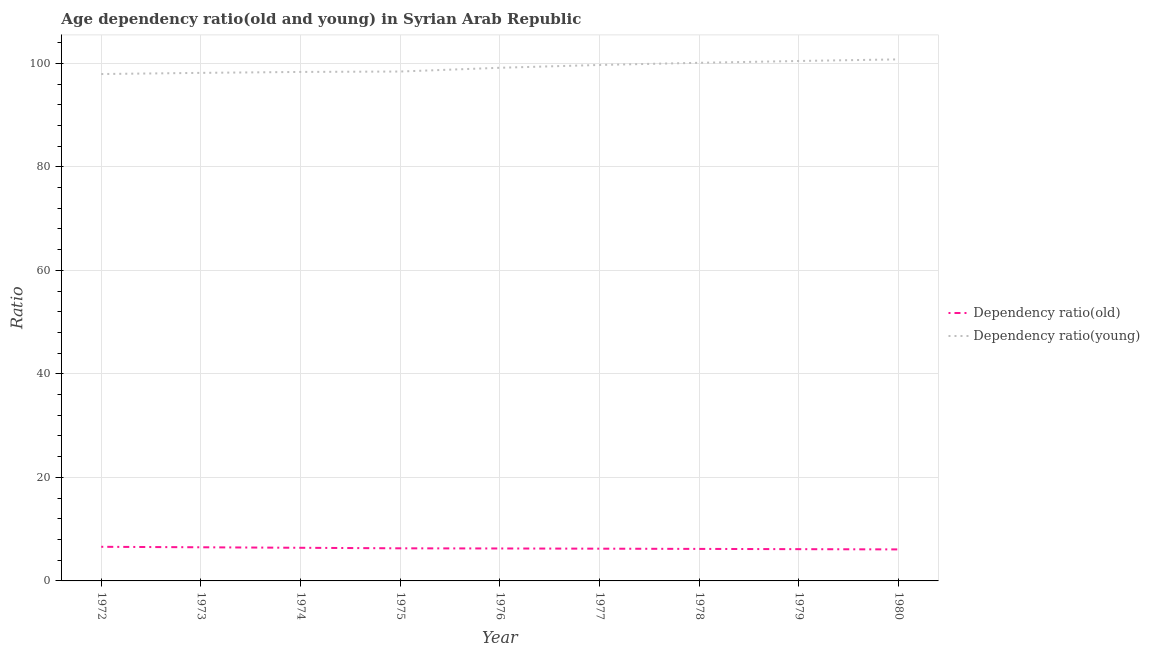Does the line corresponding to age dependency ratio(young) intersect with the line corresponding to age dependency ratio(old)?
Your answer should be very brief. No. Is the number of lines equal to the number of legend labels?
Provide a short and direct response. Yes. What is the age dependency ratio(young) in 1976?
Make the answer very short. 99.14. Across all years, what is the maximum age dependency ratio(old)?
Give a very brief answer. 6.59. Across all years, what is the minimum age dependency ratio(young)?
Offer a very short reply. 97.93. In which year was the age dependency ratio(old) maximum?
Your response must be concise. 1972. What is the total age dependency ratio(young) in the graph?
Keep it short and to the point. 893.01. What is the difference between the age dependency ratio(young) in 1977 and that in 1980?
Offer a very short reply. -1.08. What is the difference between the age dependency ratio(old) in 1979 and the age dependency ratio(young) in 1976?
Offer a terse response. -93.01. What is the average age dependency ratio(young) per year?
Your answer should be very brief. 99.22. In the year 1973, what is the difference between the age dependency ratio(young) and age dependency ratio(old)?
Make the answer very short. 91.66. In how many years, is the age dependency ratio(young) greater than 84?
Give a very brief answer. 9. What is the ratio of the age dependency ratio(young) in 1974 to that in 1978?
Give a very brief answer. 0.98. Is the age dependency ratio(young) in 1973 less than that in 1978?
Provide a succinct answer. Yes. What is the difference between the highest and the second highest age dependency ratio(young)?
Offer a terse response. 0.31. What is the difference between the highest and the lowest age dependency ratio(old)?
Make the answer very short. 0.5. Does the age dependency ratio(old) monotonically increase over the years?
Give a very brief answer. No. Is the age dependency ratio(young) strictly greater than the age dependency ratio(old) over the years?
Provide a succinct answer. Yes. Is the age dependency ratio(old) strictly less than the age dependency ratio(young) over the years?
Offer a very short reply. Yes. How many lines are there?
Offer a terse response. 2. Are the values on the major ticks of Y-axis written in scientific E-notation?
Keep it short and to the point. No. How many legend labels are there?
Offer a very short reply. 2. How are the legend labels stacked?
Your answer should be compact. Vertical. What is the title of the graph?
Provide a short and direct response. Age dependency ratio(old and young) in Syrian Arab Republic. Does "Nonresident" appear as one of the legend labels in the graph?
Ensure brevity in your answer.  No. What is the label or title of the Y-axis?
Ensure brevity in your answer.  Ratio. What is the Ratio in Dependency ratio(old) in 1972?
Offer a very short reply. 6.59. What is the Ratio in Dependency ratio(young) in 1972?
Give a very brief answer. 97.93. What is the Ratio of Dependency ratio(old) in 1973?
Offer a very short reply. 6.5. What is the Ratio of Dependency ratio(young) in 1973?
Provide a short and direct response. 98.16. What is the Ratio in Dependency ratio(old) in 1974?
Provide a short and direct response. 6.4. What is the Ratio in Dependency ratio(young) in 1974?
Your response must be concise. 98.34. What is the Ratio of Dependency ratio(old) in 1975?
Keep it short and to the point. 6.3. What is the Ratio in Dependency ratio(young) in 1975?
Ensure brevity in your answer.  98.42. What is the Ratio of Dependency ratio(old) in 1976?
Your answer should be compact. 6.27. What is the Ratio of Dependency ratio(young) in 1976?
Provide a short and direct response. 99.14. What is the Ratio of Dependency ratio(old) in 1977?
Your response must be concise. 6.23. What is the Ratio of Dependency ratio(young) in 1977?
Offer a very short reply. 99.69. What is the Ratio in Dependency ratio(old) in 1978?
Give a very brief answer. 6.19. What is the Ratio of Dependency ratio(young) in 1978?
Keep it short and to the point. 100.1. What is the Ratio in Dependency ratio(old) in 1979?
Your answer should be very brief. 6.14. What is the Ratio in Dependency ratio(young) in 1979?
Provide a succinct answer. 100.46. What is the Ratio in Dependency ratio(old) in 1980?
Offer a terse response. 6.09. What is the Ratio of Dependency ratio(young) in 1980?
Ensure brevity in your answer.  100.77. Across all years, what is the maximum Ratio in Dependency ratio(old)?
Give a very brief answer. 6.59. Across all years, what is the maximum Ratio of Dependency ratio(young)?
Your response must be concise. 100.77. Across all years, what is the minimum Ratio of Dependency ratio(old)?
Provide a short and direct response. 6.09. Across all years, what is the minimum Ratio in Dependency ratio(young)?
Offer a terse response. 97.93. What is the total Ratio in Dependency ratio(old) in the graph?
Your answer should be compact. 56.71. What is the total Ratio in Dependency ratio(young) in the graph?
Make the answer very short. 893.01. What is the difference between the Ratio in Dependency ratio(old) in 1972 and that in 1973?
Offer a very short reply. 0.09. What is the difference between the Ratio of Dependency ratio(young) in 1972 and that in 1973?
Your response must be concise. -0.22. What is the difference between the Ratio in Dependency ratio(old) in 1972 and that in 1974?
Your answer should be very brief. 0.19. What is the difference between the Ratio in Dependency ratio(young) in 1972 and that in 1974?
Make the answer very short. -0.41. What is the difference between the Ratio in Dependency ratio(old) in 1972 and that in 1975?
Keep it short and to the point. 0.29. What is the difference between the Ratio in Dependency ratio(young) in 1972 and that in 1975?
Ensure brevity in your answer.  -0.49. What is the difference between the Ratio in Dependency ratio(old) in 1972 and that in 1976?
Offer a terse response. 0.32. What is the difference between the Ratio of Dependency ratio(young) in 1972 and that in 1976?
Keep it short and to the point. -1.21. What is the difference between the Ratio in Dependency ratio(old) in 1972 and that in 1977?
Your answer should be compact. 0.36. What is the difference between the Ratio in Dependency ratio(young) in 1972 and that in 1977?
Ensure brevity in your answer.  -1.75. What is the difference between the Ratio in Dependency ratio(old) in 1972 and that in 1978?
Your answer should be very brief. 0.41. What is the difference between the Ratio of Dependency ratio(young) in 1972 and that in 1978?
Your response must be concise. -2.17. What is the difference between the Ratio of Dependency ratio(old) in 1972 and that in 1979?
Your answer should be compact. 0.45. What is the difference between the Ratio in Dependency ratio(young) in 1972 and that in 1979?
Keep it short and to the point. -2.52. What is the difference between the Ratio in Dependency ratio(old) in 1972 and that in 1980?
Your answer should be very brief. 0.5. What is the difference between the Ratio in Dependency ratio(young) in 1972 and that in 1980?
Offer a very short reply. -2.83. What is the difference between the Ratio in Dependency ratio(old) in 1973 and that in 1974?
Your answer should be very brief. 0.1. What is the difference between the Ratio in Dependency ratio(young) in 1973 and that in 1974?
Your answer should be compact. -0.18. What is the difference between the Ratio of Dependency ratio(old) in 1973 and that in 1975?
Offer a terse response. 0.2. What is the difference between the Ratio of Dependency ratio(young) in 1973 and that in 1975?
Offer a very short reply. -0.26. What is the difference between the Ratio in Dependency ratio(old) in 1973 and that in 1976?
Offer a terse response. 0.23. What is the difference between the Ratio of Dependency ratio(young) in 1973 and that in 1976?
Your response must be concise. -0.99. What is the difference between the Ratio in Dependency ratio(old) in 1973 and that in 1977?
Ensure brevity in your answer.  0.27. What is the difference between the Ratio of Dependency ratio(young) in 1973 and that in 1977?
Make the answer very short. -1.53. What is the difference between the Ratio of Dependency ratio(old) in 1973 and that in 1978?
Provide a short and direct response. 0.31. What is the difference between the Ratio in Dependency ratio(young) in 1973 and that in 1978?
Provide a succinct answer. -1.95. What is the difference between the Ratio in Dependency ratio(old) in 1973 and that in 1979?
Give a very brief answer. 0.36. What is the difference between the Ratio in Dependency ratio(young) in 1973 and that in 1979?
Give a very brief answer. -2.3. What is the difference between the Ratio in Dependency ratio(old) in 1973 and that in 1980?
Your answer should be compact. 0.41. What is the difference between the Ratio of Dependency ratio(young) in 1973 and that in 1980?
Your response must be concise. -2.61. What is the difference between the Ratio of Dependency ratio(old) in 1974 and that in 1975?
Keep it short and to the point. 0.1. What is the difference between the Ratio in Dependency ratio(young) in 1974 and that in 1975?
Your answer should be compact. -0.08. What is the difference between the Ratio in Dependency ratio(old) in 1974 and that in 1976?
Give a very brief answer. 0.13. What is the difference between the Ratio in Dependency ratio(young) in 1974 and that in 1976?
Give a very brief answer. -0.8. What is the difference between the Ratio in Dependency ratio(old) in 1974 and that in 1977?
Offer a very short reply. 0.17. What is the difference between the Ratio of Dependency ratio(young) in 1974 and that in 1977?
Make the answer very short. -1.35. What is the difference between the Ratio in Dependency ratio(old) in 1974 and that in 1978?
Give a very brief answer. 0.22. What is the difference between the Ratio of Dependency ratio(young) in 1974 and that in 1978?
Offer a very short reply. -1.76. What is the difference between the Ratio in Dependency ratio(old) in 1974 and that in 1979?
Your response must be concise. 0.26. What is the difference between the Ratio in Dependency ratio(young) in 1974 and that in 1979?
Keep it short and to the point. -2.12. What is the difference between the Ratio in Dependency ratio(old) in 1974 and that in 1980?
Provide a succinct answer. 0.31. What is the difference between the Ratio in Dependency ratio(young) in 1974 and that in 1980?
Your response must be concise. -2.43. What is the difference between the Ratio in Dependency ratio(old) in 1975 and that in 1976?
Make the answer very short. 0.03. What is the difference between the Ratio of Dependency ratio(young) in 1975 and that in 1976?
Provide a short and direct response. -0.72. What is the difference between the Ratio in Dependency ratio(old) in 1975 and that in 1977?
Offer a very short reply. 0.07. What is the difference between the Ratio in Dependency ratio(young) in 1975 and that in 1977?
Keep it short and to the point. -1.27. What is the difference between the Ratio in Dependency ratio(old) in 1975 and that in 1978?
Offer a terse response. 0.11. What is the difference between the Ratio of Dependency ratio(young) in 1975 and that in 1978?
Make the answer very short. -1.68. What is the difference between the Ratio in Dependency ratio(old) in 1975 and that in 1979?
Give a very brief answer. 0.16. What is the difference between the Ratio in Dependency ratio(young) in 1975 and that in 1979?
Offer a terse response. -2.04. What is the difference between the Ratio of Dependency ratio(old) in 1975 and that in 1980?
Your response must be concise. 0.21. What is the difference between the Ratio in Dependency ratio(young) in 1975 and that in 1980?
Provide a short and direct response. -2.35. What is the difference between the Ratio in Dependency ratio(old) in 1976 and that in 1977?
Offer a terse response. 0.04. What is the difference between the Ratio in Dependency ratio(young) in 1976 and that in 1977?
Your answer should be compact. -0.55. What is the difference between the Ratio of Dependency ratio(old) in 1976 and that in 1978?
Your answer should be compact. 0.08. What is the difference between the Ratio in Dependency ratio(young) in 1976 and that in 1978?
Provide a succinct answer. -0.96. What is the difference between the Ratio of Dependency ratio(old) in 1976 and that in 1979?
Offer a terse response. 0.13. What is the difference between the Ratio in Dependency ratio(young) in 1976 and that in 1979?
Provide a short and direct response. -1.31. What is the difference between the Ratio in Dependency ratio(old) in 1976 and that in 1980?
Make the answer very short. 0.18. What is the difference between the Ratio of Dependency ratio(young) in 1976 and that in 1980?
Your response must be concise. -1.62. What is the difference between the Ratio in Dependency ratio(old) in 1977 and that in 1978?
Offer a very short reply. 0.04. What is the difference between the Ratio of Dependency ratio(young) in 1977 and that in 1978?
Make the answer very short. -0.41. What is the difference between the Ratio of Dependency ratio(old) in 1977 and that in 1979?
Provide a succinct answer. 0.09. What is the difference between the Ratio of Dependency ratio(young) in 1977 and that in 1979?
Ensure brevity in your answer.  -0.77. What is the difference between the Ratio of Dependency ratio(old) in 1977 and that in 1980?
Your response must be concise. 0.14. What is the difference between the Ratio in Dependency ratio(young) in 1977 and that in 1980?
Provide a short and direct response. -1.08. What is the difference between the Ratio in Dependency ratio(old) in 1978 and that in 1979?
Keep it short and to the point. 0.05. What is the difference between the Ratio of Dependency ratio(young) in 1978 and that in 1979?
Give a very brief answer. -0.35. What is the difference between the Ratio in Dependency ratio(old) in 1978 and that in 1980?
Offer a terse response. 0.1. What is the difference between the Ratio in Dependency ratio(young) in 1978 and that in 1980?
Your answer should be compact. -0.66. What is the difference between the Ratio of Dependency ratio(old) in 1979 and that in 1980?
Make the answer very short. 0.05. What is the difference between the Ratio of Dependency ratio(young) in 1979 and that in 1980?
Give a very brief answer. -0.31. What is the difference between the Ratio in Dependency ratio(old) in 1972 and the Ratio in Dependency ratio(young) in 1973?
Offer a very short reply. -91.57. What is the difference between the Ratio in Dependency ratio(old) in 1972 and the Ratio in Dependency ratio(young) in 1974?
Ensure brevity in your answer.  -91.75. What is the difference between the Ratio in Dependency ratio(old) in 1972 and the Ratio in Dependency ratio(young) in 1975?
Provide a succinct answer. -91.83. What is the difference between the Ratio in Dependency ratio(old) in 1972 and the Ratio in Dependency ratio(young) in 1976?
Ensure brevity in your answer.  -92.55. What is the difference between the Ratio in Dependency ratio(old) in 1972 and the Ratio in Dependency ratio(young) in 1977?
Your response must be concise. -93.1. What is the difference between the Ratio in Dependency ratio(old) in 1972 and the Ratio in Dependency ratio(young) in 1978?
Your response must be concise. -93.51. What is the difference between the Ratio of Dependency ratio(old) in 1972 and the Ratio of Dependency ratio(young) in 1979?
Offer a very short reply. -93.86. What is the difference between the Ratio in Dependency ratio(old) in 1972 and the Ratio in Dependency ratio(young) in 1980?
Your answer should be compact. -94.17. What is the difference between the Ratio in Dependency ratio(old) in 1973 and the Ratio in Dependency ratio(young) in 1974?
Your answer should be compact. -91.84. What is the difference between the Ratio in Dependency ratio(old) in 1973 and the Ratio in Dependency ratio(young) in 1975?
Your answer should be compact. -91.92. What is the difference between the Ratio in Dependency ratio(old) in 1973 and the Ratio in Dependency ratio(young) in 1976?
Offer a terse response. -92.64. What is the difference between the Ratio in Dependency ratio(old) in 1973 and the Ratio in Dependency ratio(young) in 1977?
Make the answer very short. -93.19. What is the difference between the Ratio of Dependency ratio(old) in 1973 and the Ratio of Dependency ratio(young) in 1978?
Give a very brief answer. -93.6. What is the difference between the Ratio of Dependency ratio(old) in 1973 and the Ratio of Dependency ratio(young) in 1979?
Offer a very short reply. -93.96. What is the difference between the Ratio in Dependency ratio(old) in 1973 and the Ratio in Dependency ratio(young) in 1980?
Keep it short and to the point. -94.27. What is the difference between the Ratio in Dependency ratio(old) in 1974 and the Ratio in Dependency ratio(young) in 1975?
Your answer should be compact. -92.02. What is the difference between the Ratio of Dependency ratio(old) in 1974 and the Ratio of Dependency ratio(young) in 1976?
Your answer should be very brief. -92.74. What is the difference between the Ratio of Dependency ratio(old) in 1974 and the Ratio of Dependency ratio(young) in 1977?
Provide a succinct answer. -93.29. What is the difference between the Ratio in Dependency ratio(old) in 1974 and the Ratio in Dependency ratio(young) in 1978?
Your answer should be compact. -93.7. What is the difference between the Ratio of Dependency ratio(old) in 1974 and the Ratio of Dependency ratio(young) in 1979?
Offer a very short reply. -94.05. What is the difference between the Ratio in Dependency ratio(old) in 1974 and the Ratio in Dependency ratio(young) in 1980?
Your answer should be compact. -94.36. What is the difference between the Ratio in Dependency ratio(old) in 1975 and the Ratio in Dependency ratio(young) in 1976?
Your answer should be compact. -92.84. What is the difference between the Ratio of Dependency ratio(old) in 1975 and the Ratio of Dependency ratio(young) in 1977?
Your answer should be very brief. -93.39. What is the difference between the Ratio in Dependency ratio(old) in 1975 and the Ratio in Dependency ratio(young) in 1978?
Your answer should be compact. -93.8. What is the difference between the Ratio of Dependency ratio(old) in 1975 and the Ratio of Dependency ratio(young) in 1979?
Your answer should be compact. -94.16. What is the difference between the Ratio in Dependency ratio(old) in 1975 and the Ratio in Dependency ratio(young) in 1980?
Your answer should be compact. -94.47. What is the difference between the Ratio in Dependency ratio(old) in 1976 and the Ratio in Dependency ratio(young) in 1977?
Your response must be concise. -93.42. What is the difference between the Ratio in Dependency ratio(old) in 1976 and the Ratio in Dependency ratio(young) in 1978?
Give a very brief answer. -93.83. What is the difference between the Ratio of Dependency ratio(old) in 1976 and the Ratio of Dependency ratio(young) in 1979?
Provide a succinct answer. -94.19. What is the difference between the Ratio of Dependency ratio(old) in 1976 and the Ratio of Dependency ratio(young) in 1980?
Offer a terse response. -94.5. What is the difference between the Ratio of Dependency ratio(old) in 1977 and the Ratio of Dependency ratio(young) in 1978?
Make the answer very short. -93.87. What is the difference between the Ratio of Dependency ratio(old) in 1977 and the Ratio of Dependency ratio(young) in 1979?
Your answer should be very brief. -94.23. What is the difference between the Ratio of Dependency ratio(old) in 1977 and the Ratio of Dependency ratio(young) in 1980?
Offer a very short reply. -94.54. What is the difference between the Ratio of Dependency ratio(old) in 1978 and the Ratio of Dependency ratio(young) in 1979?
Provide a short and direct response. -94.27. What is the difference between the Ratio in Dependency ratio(old) in 1978 and the Ratio in Dependency ratio(young) in 1980?
Your answer should be compact. -94.58. What is the difference between the Ratio of Dependency ratio(old) in 1979 and the Ratio of Dependency ratio(young) in 1980?
Your answer should be compact. -94.63. What is the average Ratio in Dependency ratio(old) per year?
Make the answer very short. 6.3. What is the average Ratio in Dependency ratio(young) per year?
Ensure brevity in your answer.  99.22. In the year 1972, what is the difference between the Ratio in Dependency ratio(old) and Ratio in Dependency ratio(young)?
Your answer should be very brief. -91.34. In the year 1973, what is the difference between the Ratio in Dependency ratio(old) and Ratio in Dependency ratio(young)?
Give a very brief answer. -91.66. In the year 1974, what is the difference between the Ratio of Dependency ratio(old) and Ratio of Dependency ratio(young)?
Offer a terse response. -91.94. In the year 1975, what is the difference between the Ratio of Dependency ratio(old) and Ratio of Dependency ratio(young)?
Ensure brevity in your answer.  -92.12. In the year 1976, what is the difference between the Ratio in Dependency ratio(old) and Ratio in Dependency ratio(young)?
Your answer should be compact. -92.87. In the year 1977, what is the difference between the Ratio in Dependency ratio(old) and Ratio in Dependency ratio(young)?
Ensure brevity in your answer.  -93.46. In the year 1978, what is the difference between the Ratio of Dependency ratio(old) and Ratio of Dependency ratio(young)?
Your answer should be compact. -93.92. In the year 1979, what is the difference between the Ratio of Dependency ratio(old) and Ratio of Dependency ratio(young)?
Make the answer very short. -94.32. In the year 1980, what is the difference between the Ratio of Dependency ratio(old) and Ratio of Dependency ratio(young)?
Provide a succinct answer. -94.68. What is the ratio of the Ratio of Dependency ratio(old) in 1972 to that in 1973?
Provide a short and direct response. 1.01. What is the ratio of the Ratio of Dependency ratio(old) in 1972 to that in 1974?
Ensure brevity in your answer.  1.03. What is the ratio of the Ratio in Dependency ratio(young) in 1972 to that in 1974?
Ensure brevity in your answer.  1. What is the ratio of the Ratio of Dependency ratio(old) in 1972 to that in 1975?
Give a very brief answer. 1.05. What is the ratio of the Ratio in Dependency ratio(young) in 1972 to that in 1975?
Give a very brief answer. 1. What is the ratio of the Ratio of Dependency ratio(old) in 1972 to that in 1976?
Ensure brevity in your answer.  1.05. What is the ratio of the Ratio in Dependency ratio(young) in 1972 to that in 1976?
Your answer should be compact. 0.99. What is the ratio of the Ratio in Dependency ratio(old) in 1972 to that in 1977?
Ensure brevity in your answer.  1.06. What is the ratio of the Ratio in Dependency ratio(young) in 1972 to that in 1977?
Your answer should be compact. 0.98. What is the ratio of the Ratio of Dependency ratio(old) in 1972 to that in 1978?
Offer a terse response. 1.07. What is the ratio of the Ratio of Dependency ratio(young) in 1972 to that in 1978?
Your answer should be very brief. 0.98. What is the ratio of the Ratio of Dependency ratio(old) in 1972 to that in 1979?
Keep it short and to the point. 1.07. What is the ratio of the Ratio in Dependency ratio(young) in 1972 to that in 1979?
Your response must be concise. 0.97. What is the ratio of the Ratio of Dependency ratio(old) in 1972 to that in 1980?
Make the answer very short. 1.08. What is the ratio of the Ratio of Dependency ratio(young) in 1972 to that in 1980?
Your answer should be compact. 0.97. What is the ratio of the Ratio of Dependency ratio(old) in 1973 to that in 1974?
Ensure brevity in your answer.  1.02. What is the ratio of the Ratio in Dependency ratio(old) in 1973 to that in 1975?
Ensure brevity in your answer.  1.03. What is the ratio of the Ratio in Dependency ratio(old) in 1973 to that in 1976?
Make the answer very short. 1.04. What is the ratio of the Ratio of Dependency ratio(young) in 1973 to that in 1976?
Your answer should be compact. 0.99. What is the ratio of the Ratio in Dependency ratio(old) in 1973 to that in 1977?
Your answer should be compact. 1.04. What is the ratio of the Ratio of Dependency ratio(young) in 1973 to that in 1977?
Provide a short and direct response. 0.98. What is the ratio of the Ratio in Dependency ratio(old) in 1973 to that in 1978?
Offer a terse response. 1.05. What is the ratio of the Ratio of Dependency ratio(young) in 1973 to that in 1978?
Ensure brevity in your answer.  0.98. What is the ratio of the Ratio of Dependency ratio(old) in 1973 to that in 1979?
Ensure brevity in your answer.  1.06. What is the ratio of the Ratio of Dependency ratio(young) in 1973 to that in 1979?
Your answer should be compact. 0.98. What is the ratio of the Ratio in Dependency ratio(old) in 1973 to that in 1980?
Your answer should be very brief. 1.07. What is the ratio of the Ratio of Dependency ratio(young) in 1973 to that in 1980?
Make the answer very short. 0.97. What is the ratio of the Ratio of Dependency ratio(old) in 1974 to that in 1975?
Offer a terse response. 1.02. What is the ratio of the Ratio in Dependency ratio(old) in 1974 to that in 1976?
Give a very brief answer. 1.02. What is the ratio of the Ratio of Dependency ratio(young) in 1974 to that in 1976?
Give a very brief answer. 0.99. What is the ratio of the Ratio of Dependency ratio(old) in 1974 to that in 1977?
Your answer should be very brief. 1.03. What is the ratio of the Ratio in Dependency ratio(young) in 1974 to that in 1977?
Provide a succinct answer. 0.99. What is the ratio of the Ratio in Dependency ratio(old) in 1974 to that in 1978?
Your answer should be compact. 1.03. What is the ratio of the Ratio in Dependency ratio(young) in 1974 to that in 1978?
Give a very brief answer. 0.98. What is the ratio of the Ratio of Dependency ratio(old) in 1974 to that in 1979?
Your answer should be very brief. 1.04. What is the ratio of the Ratio of Dependency ratio(young) in 1974 to that in 1979?
Provide a succinct answer. 0.98. What is the ratio of the Ratio in Dependency ratio(old) in 1974 to that in 1980?
Make the answer very short. 1.05. What is the ratio of the Ratio of Dependency ratio(young) in 1974 to that in 1980?
Offer a terse response. 0.98. What is the ratio of the Ratio of Dependency ratio(old) in 1975 to that in 1976?
Your response must be concise. 1. What is the ratio of the Ratio in Dependency ratio(young) in 1975 to that in 1976?
Make the answer very short. 0.99. What is the ratio of the Ratio of Dependency ratio(old) in 1975 to that in 1977?
Give a very brief answer. 1.01. What is the ratio of the Ratio of Dependency ratio(young) in 1975 to that in 1977?
Make the answer very short. 0.99. What is the ratio of the Ratio in Dependency ratio(old) in 1975 to that in 1978?
Your response must be concise. 1.02. What is the ratio of the Ratio of Dependency ratio(young) in 1975 to that in 1978?
Your answer should be compact. 0.98. What is the ratio of the Ratio of Dependency ratio(old) in 1975 to that in 1979?
Offer a very short reply. 1.03. What is the ratio of the Ratio in Dependency ratio(young) in 1975 to that in 1979?
Offer a very short reply. 0.98. What is the ratio of the Ratio of Dependency ratio(old) in 1975 to that in 1980?
Your answer should be compact. 1.03. What is the ratio of the Ratio in Dependency ratio(young) in 1975 to that in 1980?
Provide a short and direct response. 0.98. What is the ratio of the Ratio in Dependency ratio(old) in 1976 to that in 1977?
Ensure brevity in your answer.  1.01. What is the ratio of the Ratio of Dependency ratio(young) in 1976 to that in 1977?
Provide a succinct answer. 0.99. What is the ratio of the Ratio of Dependency ratio(old) in 1976 to that in 1978?
Give a very brief answer. 1.01. What is the ratio of the Ratio of Dependency ratio(young) in 1976 to that in 1978?
Provide a short and direct response. 0.99. What is the ratio of the Ratio of Dependency ratio(old) in 1976 to that in 1979?
Make the answer very short. 1.02. What is the ratio of the Ratio in Dependency ratio(young) in 1976 to that in 1979?
Ensure brevity in your answer.  0.99. What is the ratio of the Ratio of Dependency ratio(old) in 1976 to that in 1980?
Your answer should be very brief. 1.03. What is the ratio of the Ratio of Dependency ratio(young) in 1976 to that in 1980?
Provide a succinct answer. 0.98. What is the ratio of the Ratio in Dependency ratio(old) in 1977 to that in 1978?
Offer a terse response. 1.01. What is the ratio of the Ratio in Dependency ratio(young) in 1977 to that in 1978?
Your answer should be very brief. 1. What is the ratio of the Ratio in Dependency ratio(old) in 1977 to that in 1979?
Ensure brevity in your answer.  1.02. What is the ratio of the Ratio of Dependency ratio(old) in 1977 to that in 1980?
Your response must be concise. 1.02. What is the ratio of the Ratio in Dependency ratio(young) in 1977 to that in 1980?
Ensure brevity in your answer.  0.99. What is the ratio of the Ratio in Dependency ratio(old) in 1978 to that in 1979?
Your answer should be very brief. 1.01. What is the ratio of the Ratio in Dependency ratio(young) in 1978 to that in 1979?
Your response must be concise. 1. What is the ratio of the Ratio in Dependency ratio(old) in 1978 to that in 1980?
Offer a very short reply. 1.02. What is the ratio of the Ratio of Dependency ratio(young) in 1978 to that in 1980?
Your response must be concise. 0.99. What is the difference between the highest and the second highest Ratio in Dependency ratio(old)?
Keep it short and to the point. 0.09. What is the difference between the highest and the second highest Ratio in Dependency ratio(young)?
Give a very brief answer. 0.31. What is the difference between the highest and the lowest Ratio of Dependency ratio(old)?
Offer a very short reply. 0.5. What is the difference between the highest and the lowest Ratio of Dependency ratio(young)?
Your answer should be compact. 2.83. 